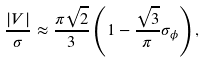Convert formula to latex. <formula><loc_0><loc_0><loc_500><loc_500>\frac { | V | } { \sigma } \approx \frac { \pi \sqrt { 2 } } { 3 } \left ( 1 - \frac { \sqrt { 3 } } { \pi } \sigma _ { \phi } \right ) ,</formula> 